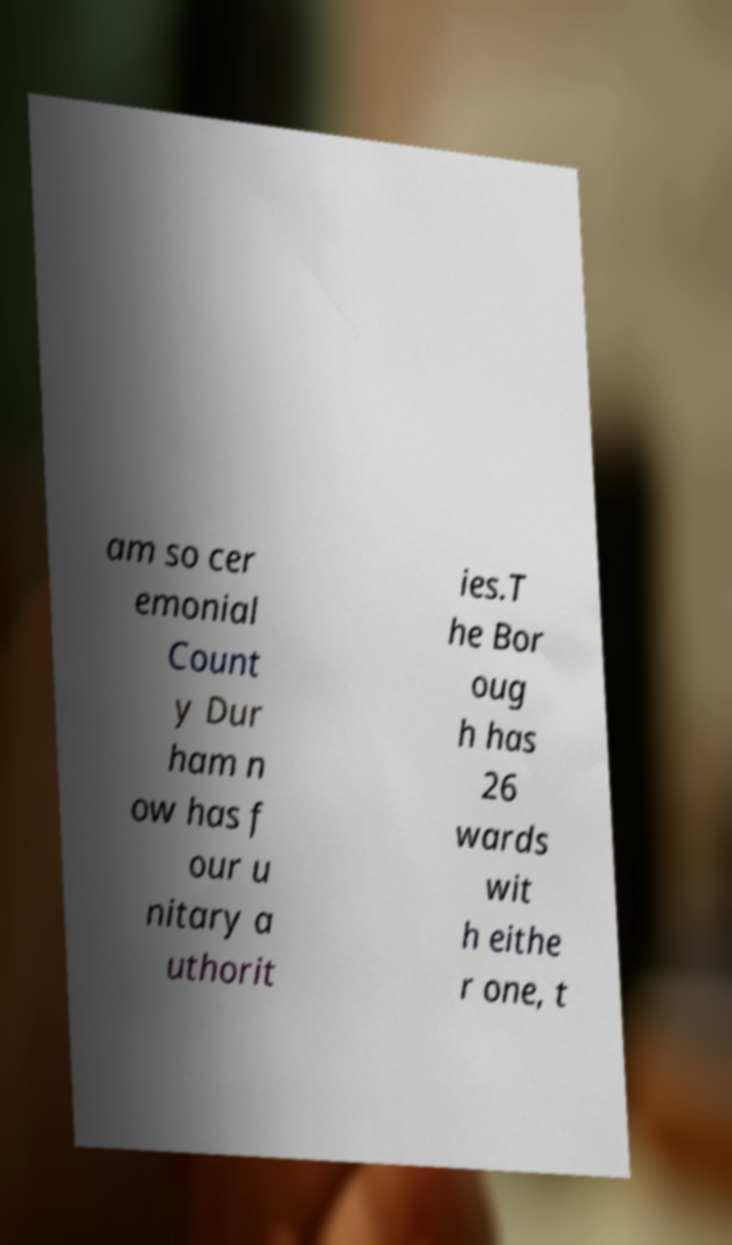For documentation purposes, I need the text within this image transcribed. Could you provide that? am so cer emonial Count y Dur ham n ow has f our u nitary a uthorit ies.T he Bor oug h has 26 wards wit h eithe r one, t 